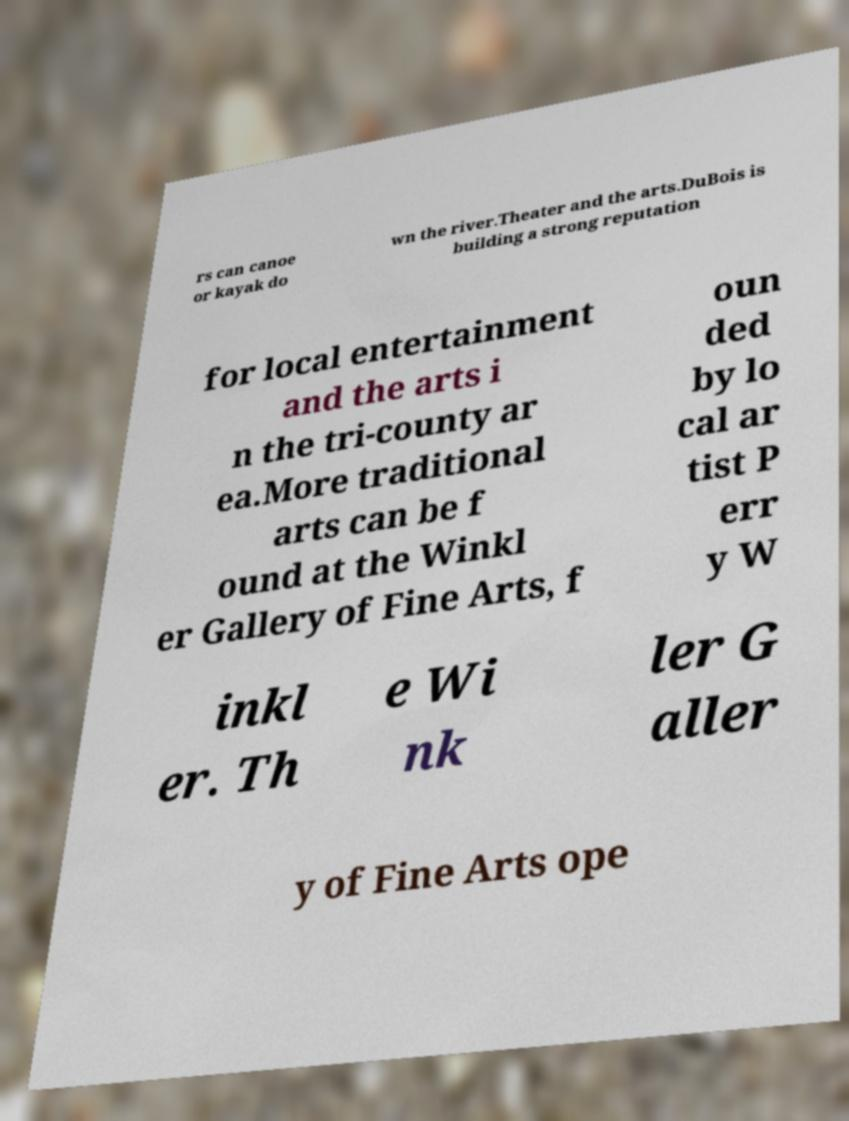There's text embedded in this image that I need extracted. Can you transcribe it verbatim? rs can canoe or kayak do wn the river.Theater and the arts.DuBois is building a strong reputation for local entertainment and the arts i n the tri-county ar ea.More traditional arts can be f ound at the Winkl er Gallery of Fine Arts, f oun ded by lo cal ar tist P err y W inkl er. Th e Wi nk ler G aller y of Fine Arts ope 